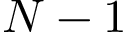<formula> <loc_0><loc_0><loc_500><loc_500>N - 1</formula> 